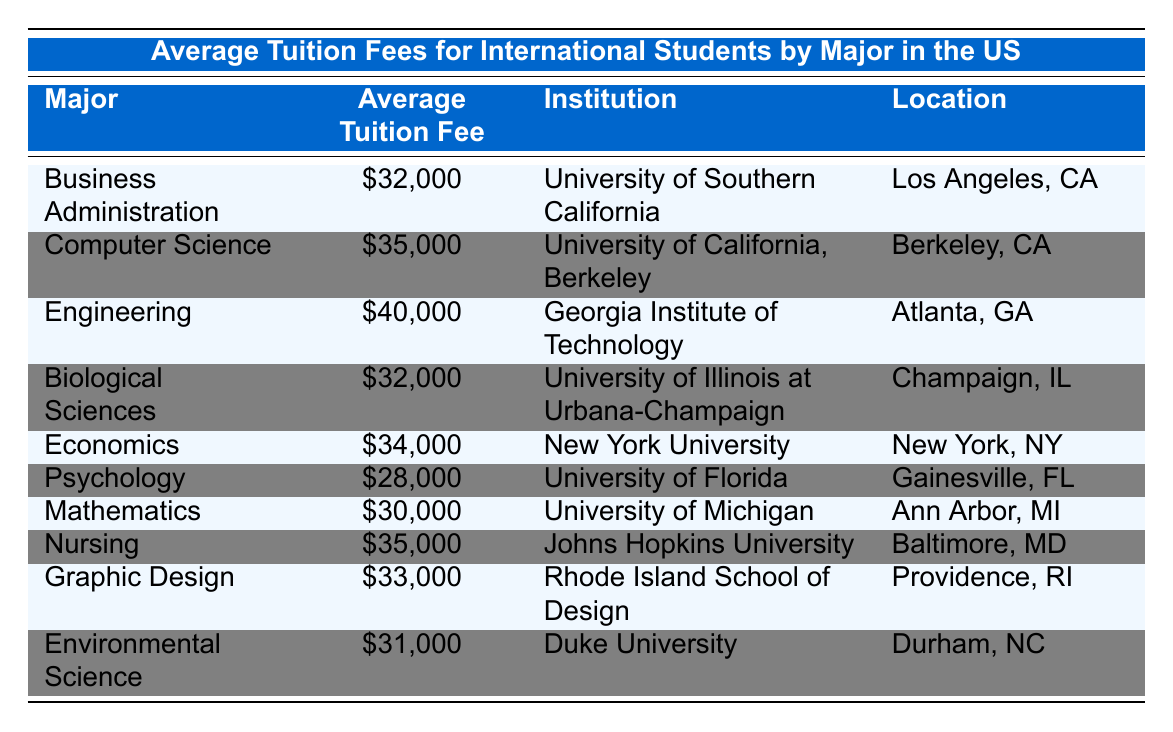What are the average tuition fees for Psychology and Environmental Science? The table lists the average tuition fees for various majors. For Psychology, the fee is 28000, and for Environmental Science, it is 31000.
Answer: 28000 and 31000 Which major has the highest average tuition fee? By examining the listed average tuition fees, Engineering has the highest tuition fee at 40000.
Answer: Engineering Is the average tuition fee for Nursing higher than that for Business Administration? Nursing has an average tuition fee of 35000 and Business Administration has 32000. Since 35000 is greater than 32000, the statement is true.
Answer: Yes What is the average tuition fee for Humanities majors based on the provided data? The student majors from the table do not include specific humanities majors but are restricted mainly to scientific and professional fields. Therefore, no direct answer can be provided.
Answer: N/A If I combine the average tuition fees of Computer Science and Mathematics, what is the total? The average tuition fee for Computer Science is 35000 and for Mathematics is 30000. Summing these gives 35000 + 30000 = 65000.
Answer: 65000 Are there any majors with an average tuition fee of 32000? Referring to the table, both Business Administration and Biological Sciences have average tuition fees of 32000. Since there are examples, the statement is true.
Answer: Yes What is the difference between the average tuition fees for Nursing and Psychology? Nursing has an average tuition fee of 35000, while Psychology has 28000. The difference calculated by subtracting the lower from the higher: 35000 - 28000 = 7000.
Answer: 7000 Which institution offers the highest tuition fee major? Looking at the table, the highest average tuition fee comes from Engineering, which is offered at Georgia Institute of Technology.
Answer: Georgia Institute of Technology What's the location of the institution offering the lowest average tuition fee? The lowest average tuition fee listed is for Psychology at University of Florida. The location noted is Gainesville, FL.
Answer: Gainesville, FL 